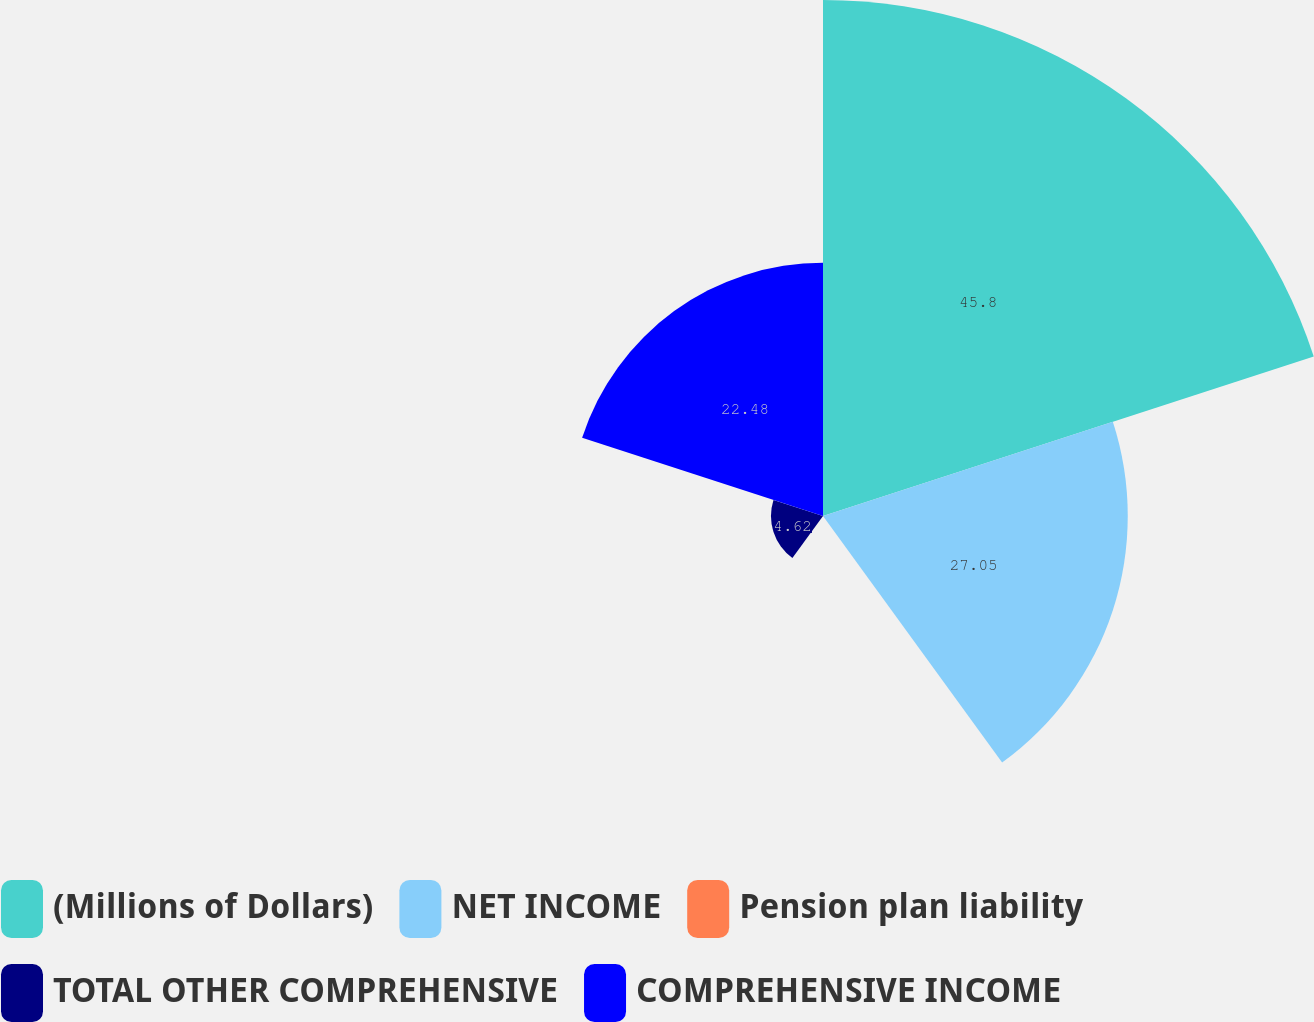Convert chart to OTSL. <chart><loc_0><loc_0><loc_500><loc_500><pie_chart><fcel>(Millions of Dollars)<fcel>NET INCOME<fcel>Pension plan liability<fcel>TOTAL OTHER COMPREHENSIVE<fcel>COMPREHENSIVE INCOME<nl><fcel>45.8%<fcel>27.05%<fcel>0.05%<fcel>4.62%<fcel>22.48%<nl></chart> 